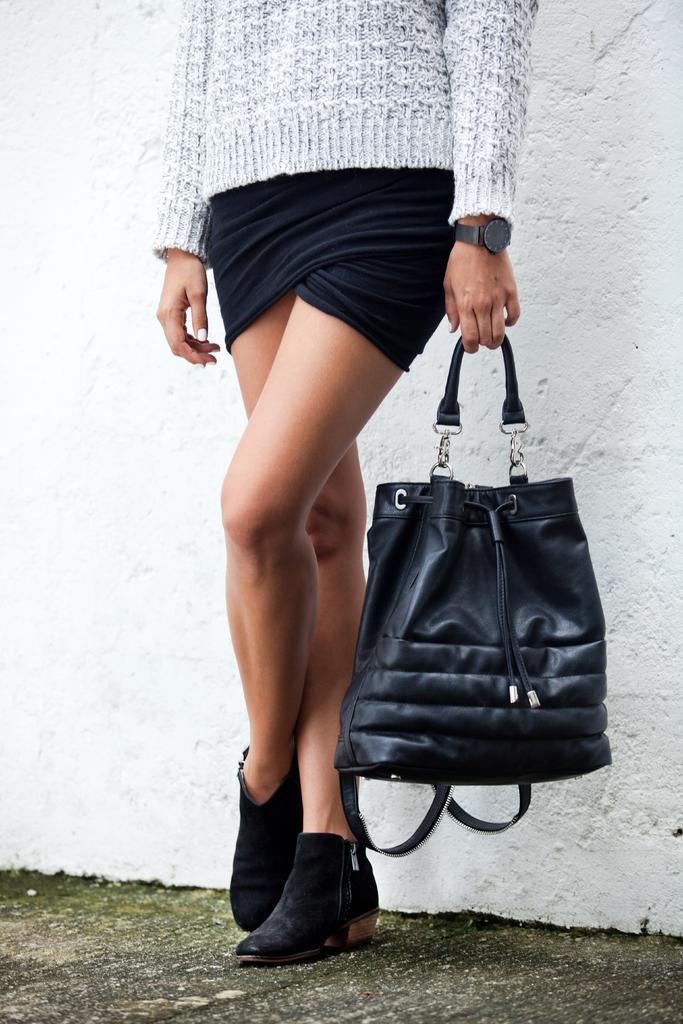Who is the main subject in the image? There is a lady in the image. What is the lady wearing on her upper body? The lady is wearing an ash top. What is the lady wearing on her lower body? The lady is wearing black shorts. What type of footwear is the lady wearing? The lady is wearing black shoes. What accessory is the lady holding in the image? The lady is holding a black bag. Is there a tent visible in the image? No, there is no tent present in the image. What type of ball is the lady holding in the image? There is no ball present in the image; the lady is holding a black bag. 